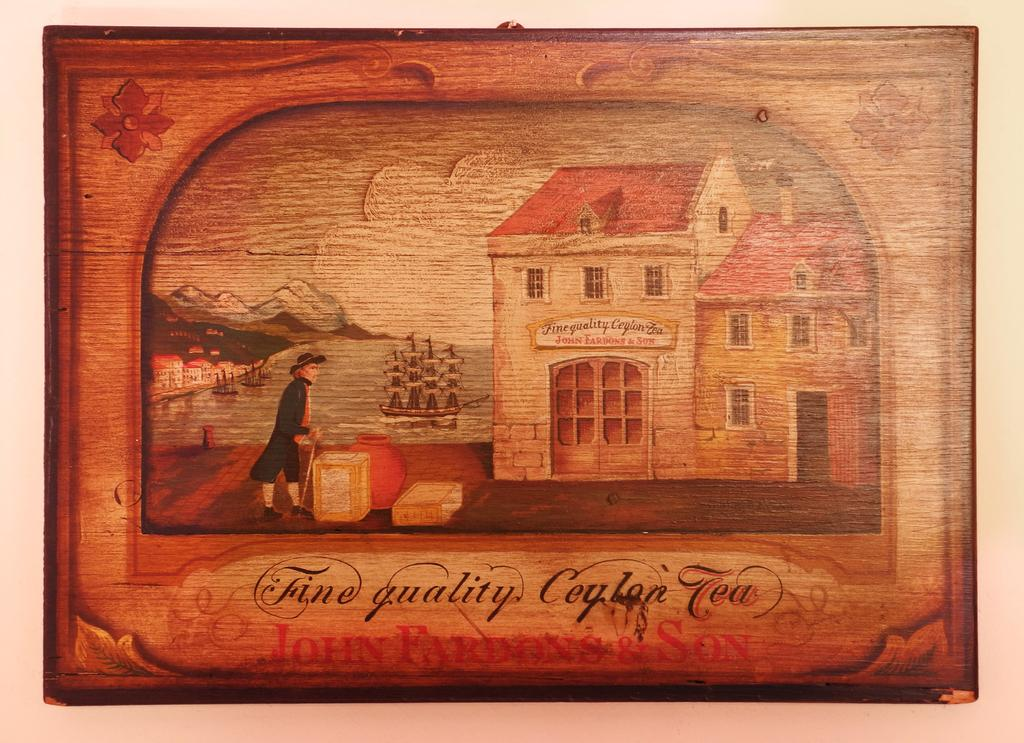Provide a one-sentence caption for the provided image. A vintage colonial looking wooden box that holds a fine quality Tea. 